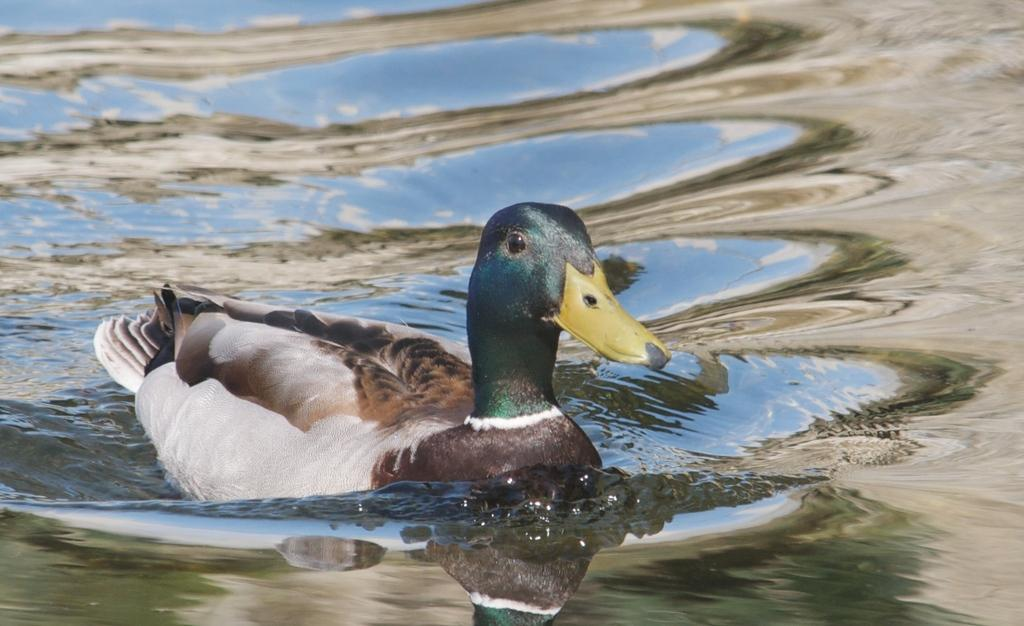What animal is present in the picture? There is a duck in the picture. What is the duck doing in the picture? The duck is swimming in the water. How many copies of the duck can be seen in the picture? There is only one duck present in the image, so there are no copies. What type of control does the duck have over the water in the picture? The duck is swimming in the water, but it does not have any control over the water itself. 